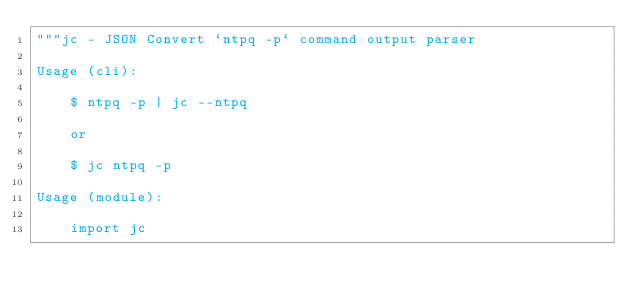<code> <loc_0><loc_0><loc_500><loc_500><_Python_>"""jc - JSON Convert `ntpq -p` command output parser

Usage (cli):

    $ ntpq -p | jc --ntpq

    or

    $ jc ntpq -p

Usage (module):

    import jc</code> 